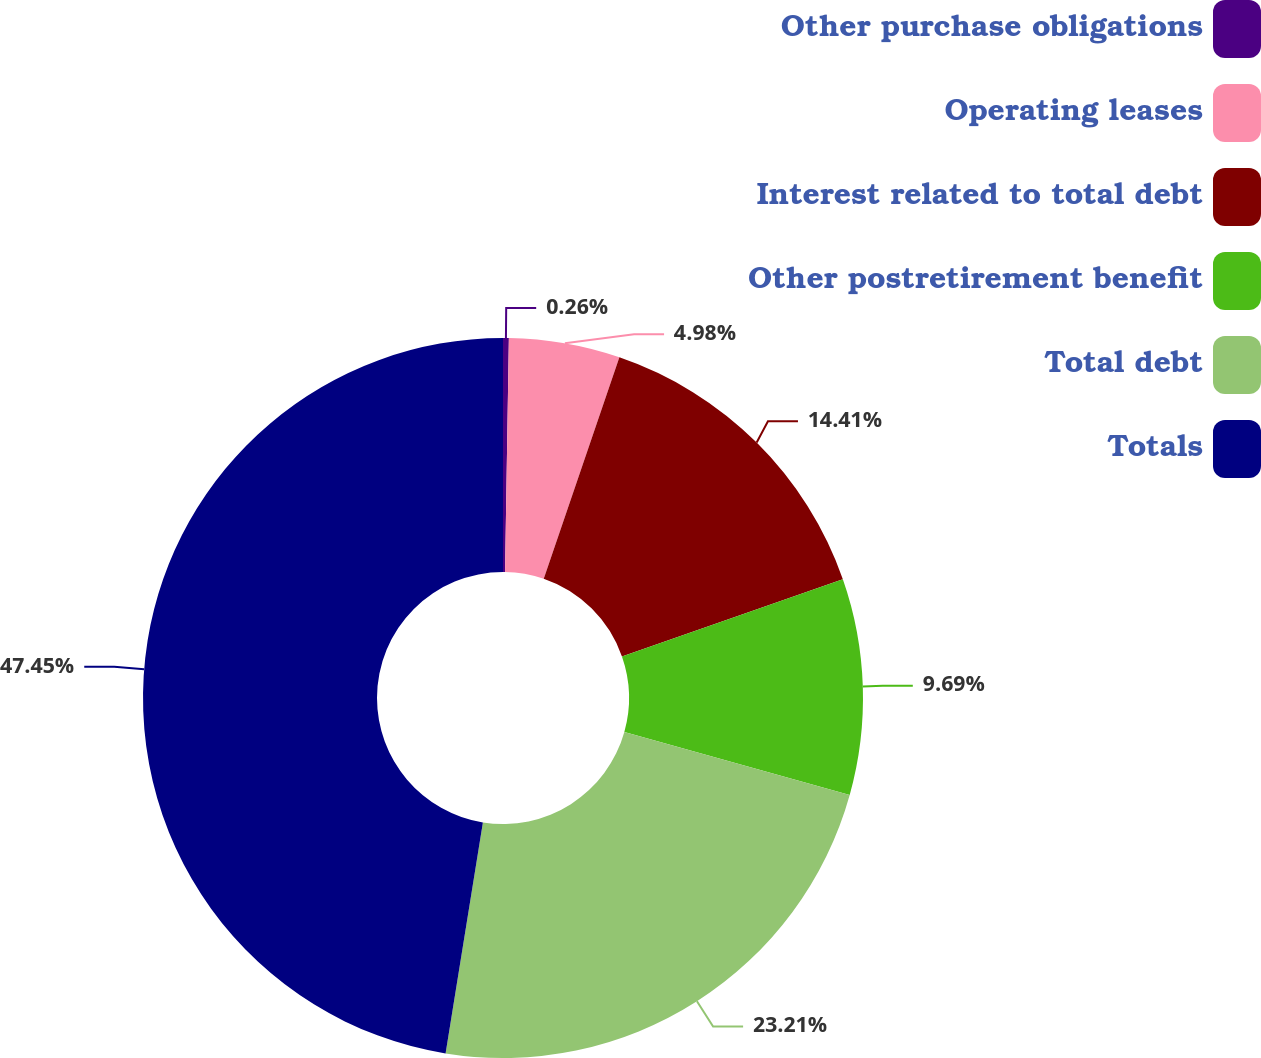<chart> <loc_0><loc_0><loc_500><loc_500><pie_chart><fcel>Other purchase obligations<fcel>Operating leases<fcel>Interest related to total debt<fcel>Other postretirement benefit<fcel>Total debt<fcel>Totals<nl><fcel>0.26%<fcel>4.98%<fcel>14.41%<fcel>9.69%<fcel>23.21%<fcel>47.45%<nl></chart> 